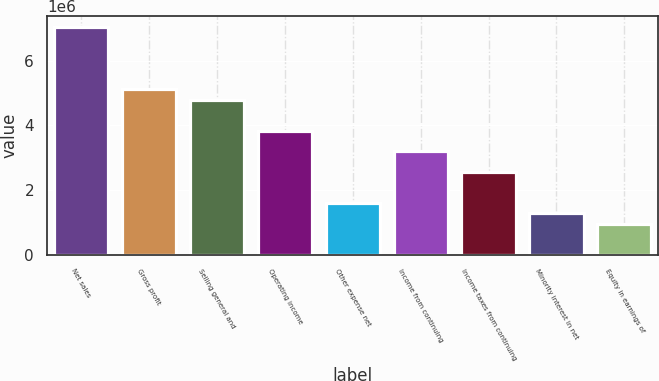Convert chart. <chart><loc_0><loc_0><loc_500><loc_500><bar_chart><fcel>Net sales<fcel>Gross profit<fcel>Selling general and<fcel>Operating income<fcel>Other expense net<fcel>Income from continuing<fcel>Income taxes from continuing<fcel>Minority interest in net<fcel>Equity in earnings of<nl><fcel>7.02687e+06<fcel>5.11045e+06<fcel>4.79105e+06<fcel>3.83284e+06<fcel>1.59702e+06<fcel>3.19403e+06<fcel>2.55523e+06<fcel>1.27761e+06<fcel>958210<nl></chart> 